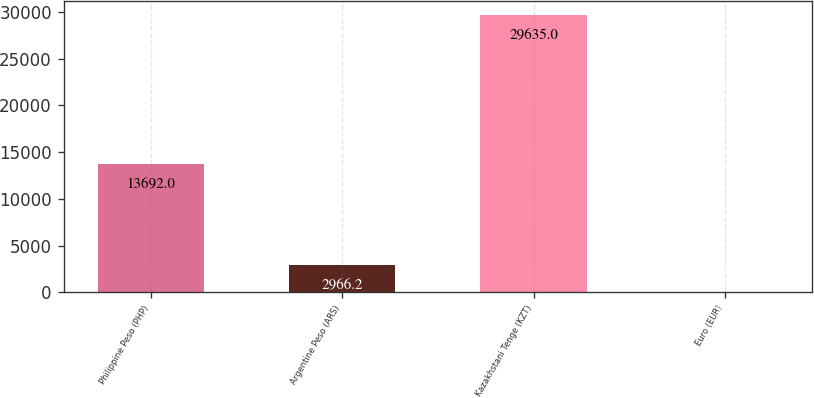Convert chart to OTSL. <chart><loc_0><loc_0><loc_500><loc_500><bar_chart><fcel>Philippine Peso (PHP)<fcel>Argentine Peso (ARS)<fcel>Kazakhstani Tenge (KZT)<fcel>Euro (EUR)<nl><fcel>13692<fcel>2966.2<fcel>29635<fcel>3<nl></chart> 